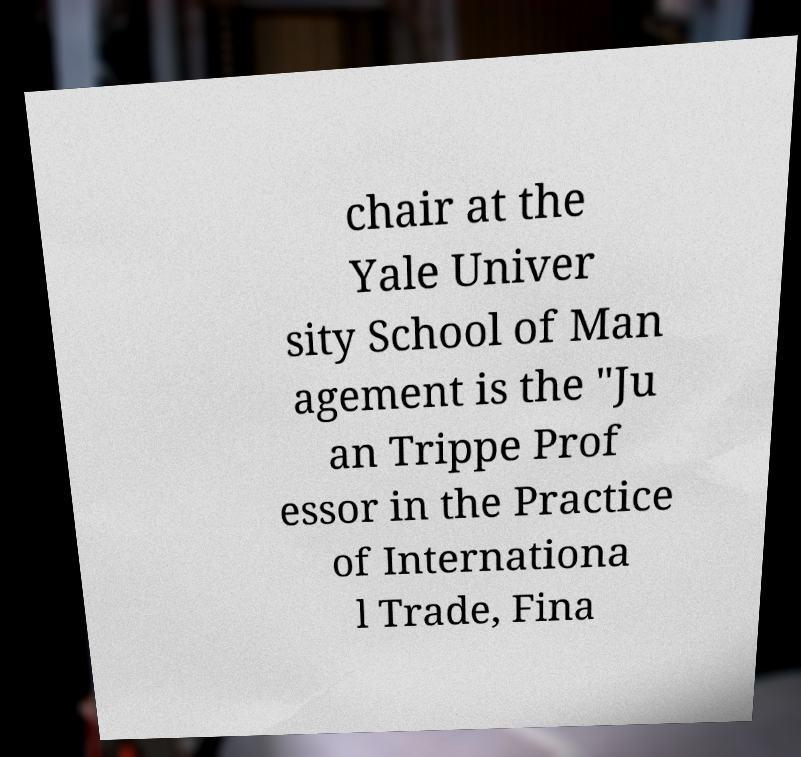Could you extract and type out the text from this image? chair at the Yale Univer sity School of Man agement is the "Ju an Trippe Prof essor in the Practice of Internationa l Trade, Fina 